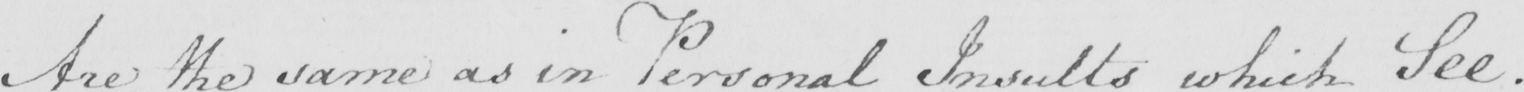What is written in this line of handwriting? Are the same as in Personal Insults which See . 